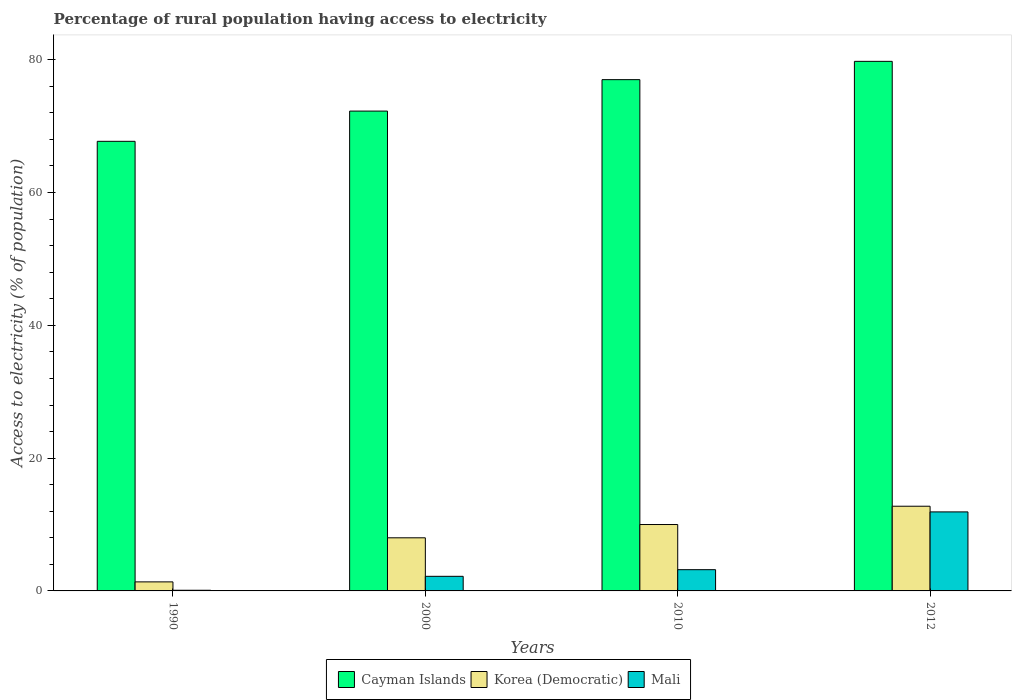How many groups of bars are there?
Your answer should be very brief. 4. Are the number of bars per tick equal to the number of legend labels?
Your answer should be compact. Yes. Are the number of bars on each tick of the X-axis equal?
Your answer should be very brief. Yes. How many bars are there on the 2nd tick from the left?
Your answer should be compact. 3. How many bars are there on the 4th tick from the right?
Your answer should be very brief. 3. Across all years, what is the maximum percentage of rural population having access to electricity in Cayman Islands?
Make the answer very short. 79.75. Across all years, what is the minimum percentage of rural population having access to electricity in Korea (Democratic)?
Provide a short and direct response. 1.36. In which year was the percentage of rural population having access to electricity in Korea (Democratic) maximum?
Your response must be concise. 2012. In which year was the percentage of rural population having access to electricity in Korea (Democratic) minimum?
Your response must be concise. 1990. What is the total percentage of rural population having access to electricity in Korea (Democratic) in the graph?
Your response must be concise. 32.11. What is the difference between the percentage of rural population having access to electricity in Korea (Democratic) in 2000 and that in 2012?
Make the answer very short. -4.75. What is the difference between the percentage of rural population having access to electricity in Mali in 2000 and the percentage of rural population having access to electricity in Cayman Islands in 2012?
Your response must be concise. -77.55. What is the average percentage of rural population having access to electricity in Korea (Democratic) per year?
Offer a terse response. 8.03. In the year 2012, what is the difference between the percentage of rural population having access to electricity in Cayman Islands and percentage of rural population having access to electricity in Mali?
Ensure brevity in your answer.  67.85. What is the ratio of the percentage of rural population having access to electricity in Mali in 2000 to that in 2012?
Make the answer very short. 0.18. What is the difference between the highest and the second highest percentage of rural population having access to electricity in Cayman Islands?
Keep it short and to the point. 2.75. What is the difference between the highest and the lowest percentage of rural population having access to electricity in Cayman Islands?
Make the answer very short. 12.04. Is the sum of the percentage of rural population having access to electricity in Mali in 1990 and 2012 greater than the maximum percentage of rural population having access to electricity in Korea (Democratic) across all years?
Keep it short and to the point. No. What does the 1st bar from the left in 1990 represents?
Your answer should be compact. Cayman Islands. What does the 3rd bar from the right in 2010 represents?
Offer a very short reply. Cayman Islands. Is it the case that in every year, the sum of the percentage of rural population having access to electricity in Korea (Democratic) and percentage of rural population having access to electricity in Cayman Islands is greater than the percentage of rural population having access to electricity in Mali?
Provide a succinct answer. Yes. Are all the bars in the graph horizontal?
Your response must be concise. No. How many years are there in the graph?
Your answer should be compact. 4. Does the graph contain any zero values?
Provide a short and direct response. No. How many legend labels are there?
Make the answer very short. 3. How are the legend labels stacked?
Ensure brevity in your answer.  Horizontal. What is the title of the graph?
Your answer should be very brief. Percentage of rural population having access to electricity. What is the label or title of the Y-axis?
Offer a terse response. Access to electricity (% of population). What is the Access to electricity (% of population) in Cayman Islands in 1990?
Your answer should be very brief. 67.71. What is the Access to electricity (% of population) in Korea (Democratic) in 1990?
Offer a very short reply. 1.36. What is the Access to electricity (% of population) in Mali in 1990?
Make the answer very short. 0.1. What is the Access to electricity (% of population) of Cayman Islands in 2000?
Your answer should be compact. 72.27. What is the Access to electricity (% of population) in Korea (Democratic) in 2000?
Offer a terse response. 8. What is the Access to electricity (% of population) in Korea (Democratic) in 2010?
Provide a short and direct response. 10. What is the Access to electricity (% of population) of Mali in 2010?
Give a very brief answer. 3.2. What is the Access to electricity (% of population) of Cayman Islands in 2012?
Give a very brief answer. 79.75. What is the Access to electricity (% of population) of Korea (Democratic) in 2012?
Provide a short and direct response. 12.75. What is the Access to electricity (% of population) of Mali in 2012?
Give a very brief answer. 11.9. Across all years, what is the maximum Access to electricity (% of population) in Cayman Islands?
Your answer should be very brief. 79.75. Across all years, what is the maximum Access to electricity (% of population) of Korea (Democratic)?
Your answer should be compact. 12.75. Across all years, what is the maximum Access to electricity (% of population) of Mali?
Keep it short and to the point. 11.9. Across all years, what is the minimum Access to electricity (% of population) of Cayman Islands?
Make the answer very short. 67.71. Across all years, what is the minimum Access to electricity (% of population) in Korea (Democratic)?
Offer a very short reply. 1.36. What is the total Access to electricity (% of population) in Cayman Islands in the graph?
Provide a short and direct response. 296.73. What is the total Access to electricity (% of population) in Korea (Democratic) in the graph?
Your response must be concise. 32.11. What is the difference between the Access to electricity (% of population) in Cayman Islands in 1990 and that in 2000?
Make the answer very short. -4.55. What is the difference between the Access to electricity (% of population) in Korea (Democratic) in 1990 and that in 2000?
Offer a very short reply. -6.64. What is the difference between the Access to electricity (% of population) in Cayman Islands in 1990 and that in 2010?
Your answer should be very brief. -9.29. What is the difference between the Access to electricity (% of population) in Korea (Democratic) in 1990 and that in 2010?
Provide a succinct answer. -8.64. What is the difference between the Access to electricity (% of population) of Cayman Islands in 1990 and that in 2012?
Offer a very short reply. -12.04. What is the difference between the Access to electricity (% of population) in Korea (Democratic) in 1990 and that in 2012?
Your response must be concise. -11.39. What is the difference between the Access to electricity (% of population) in Mali in 1990 and that in 2012?
Your response must be concise. -11.8. What is the difference between the Access to electricity (% of population) of Cayman Islands in 2000 and that in 2010?
Offer a terse response. -4.74. What is the difference between the Access to electricity (% of population) of Korea (Democratic) in 2000 and that in 2010?
Offer a terse response. -2. What is the difference between the Access to electricity (% of population) of Mali in 2000 and that in 2010?
Give a very brief answer. -1. What is the difference between the Access to electricity (% of population) in Cayman Islands in 2000 and that in 2012?
Provide a short and direct response. -7.49. What is the difference between the Access to electricity (% of population) of Korea (Democratic) in 2000 and that in 2012?
Make the answer very short. -4.75. What is the difference between the Access to electricity (% of population) of Cayman Islands in 2010 and that in 2012?
Provide a short and direct response. -2.75. What is the difference between the Access to electricity (% of population) of Korea (Democratic) in 2010 and that in 2012?
Give a very brief answer. -2.75. What is the difference between the Access to electricity (% of population) of Cayman Islands in 1990 and the Access to electricity (% of population) of Korea (Democratic) in 2000?
Offer a very short reply. 59.71. What is the difference between the Access to electricity (% of population) in Cayman Islands in 1990 and the Access to electricity (% of population) in Mali in 2000?
Offer a very short reply. 65.51. What is the difference between the Access to electricity (% of population) in Korea (Democratic) in 1990 and the Access to electricity (% of population) in Mali in 2000?
Offer a terse response. -0.84. What is the difference between the Access to electricity (% of population) of Cayman Islands in 1990 and the Access to electricity (% of population) of Korea (Democratic) in 2010?
Provide a short and direct response. 57.71. What is the difference between the Access to electricity (% of population) in Cayman Islands in 1990 and the Access to electricity (% of population) in Mali in 2010?
Give a very brief answer. 64.51. What is the difference between the Access to electricity (% of population) in Korea (Democratic) in 1990 and the Access to electricity (% of population) in Mali in 2010?
Your answer should be very brief. -1.84. What is the difference between the Access to electricity (% of population) of Cayman Islands in 1990 and the Access to electricity (% of population) of Korea (Democratic) in 2012?
Offer a very short reply. 54.96. What is the difference between the Access to electricity (% of population) in Cayman Islands in 1990 and the Access to electricity (% of population) in Mali in 2012?
Your response must be concise. 55.81. What is the difference between the Access to electricity (% of population) of Korea (Democratic) in 1990 and the Access to electricity (% of population) of Mali in 2012?
Provide a succinct answer. -10.54. What is the difference between the Access to electricity (% of population) of Cayman Islands in 2000 and the Access to electricity (% of population) of Korea (Democratic) in 2010?
Ensure brevity in your answer.  62.27. What is the difference between the Access to electricity (% of population) in Cayman Islands in 2000 and the Access to electricity (% of population) in Mali in 2010?
Provide a succinct answer. 69.06. What is the difference between the Access to electricity (% of population) of Korea (Democratic) in 2000 and the Access to electricity (% of population) of Mali in 2010?
Your answer should be compact. 4.8. What is the difference between the Access to electricity (% of population) of Cayman Islands in 2000 and the Access to electricity (% of population) of Korea (Democratic) in 2012?
Offer a very short reply. 59.51. What is the difference between the Access to electricity (% of population) of Cayman Islands in 2000 and the Access to electricity (% of population) of Mali in 2012?
Your answer should be very brief. 60.37. What is the difference between the Access to electricity (% of population) of Korea (Democratic) in 2000 and the Access to electricity (% of population) of Mali in 2012?
Keep it short and to the point. -3.9. What is the difference between the Access to electricity (% of population) of Cayman Islands in 2010 and the Access to electricity (% of population) of Korea (Democratic) in 2012?
Make the answer very short. 64.25. What is the difference between the Access to electricity (% of population) of Cayman Islands in 2010 and the Access to electricity (% of population) of Mali in 2012?
Ensure brevity in your answer.  65.1. What is the difference between the Access to electricity (% of population) of Korea (Democratic) in 2010 and the Access to electricity (% of population) of Mali in 2012?
Your answer should be very brief. -1.9. What is the average Access to electricity (% of population) of Cayman Islands per year?
Give a very brief answer. 74.18. What is the average Access to electricity (% of population) in Korea (Democratic) per year?
Offer a very short reply. 8.03. What is the average Access to electricity (% of population) of Mali per year?
Offer a very short reply. 4.35. In the year 1990, what is the difference between the Access to electricity (% of population) of Cayman Islands and Access to electricity (% of population) of Korea (Democratic)?
Keep it short and to the point. 66.35. In the year 1990, what is the difference between the Access to electricity (% of population) of Cayman Islands and Access to electricity (% of population) of Mali?
Offer a terse response. 67.61. In the year 1990, what is the difference between the Access to electricity (% of population) of Korea (Democratic) and Access to electricity (% of population) of Mali?
Give a very brief answer. 1.26. In the year 2000, what is the difference between the Access to electricity (% of population) of Cayman Islands and Access to electricity (% of population) of Korea (Democratic)?
Your response must be concise. 64.27. In the year 2000, what is the difference between the Access to electricity (% of population) in Cayman Islands and Access to electricity (% of population) in Mali?
Offer a terse response. 70.06. In the year 2000, what is the difference between the Access to electricity (% of population) in Korea (Democratic) and Access to electricity (% of population) in Mali?
Provide a succinct answer. 5.8. In the year 2010, what is the difference between the Access to electricity (% of population) in Cayman Islands and Access to electricity (% of population) in Korea (Democratic)?
Your response must be concise. 67. In the year 2010, what is the difference between the Access to electricity (% of population) of Cayman Islands and Access to electricity (% of population) of Mali?
Your answer should be very brief. 73.8. In the year 2010, what is the difference between the Access to electricity (% of population) of Korea (Democratic) and Access to electricity (% of population) of Mali?
Provide a succinct answer. 6.8. In the year 2012, what is the difference between the Access to electricity (% of population) of Cayman Islands and Access to electricity (% of population) of Mali?
Offer a terse response. 67.85. In the year 2012, what is the difference between the Access to electricity (% of population) of Korea (Democratic) and Access to electricity (% of population) of Mali?
Ensure brevity in your answer.  0.85. What is the ratio of the Access to electricity (% of population) of Cayman Islands in 1990 to that in 2000?
Ensure brevity in your answer.  0.94. What is the ratio of the Access to electricity (% of population) in Korea (Democratic) in 1990 to that in 2000?
Provide a succinct answer. 0.17. What is the ratio of the Access to electricity (% of population) in Mali in 1990 to that in 2000?
Your answer should be compact. 0.05. What is the ratio of the Access to electricity (% of population) of Cayman Islands in 1990 to that in 2010?
Make the answer very short. 0.88. What is the ratio of the Access to electricity (% of population) in Korea (Democratic) in 1990 to that in 2010?
Provide a succinct answer. 0.14. What is the ratio of the Access to electricity (% of population) of Mali in 1990 to that in 2010?
Provide a short and direct response. 0.03. What is the ratio of the Access to electricity (% of population) in Cayman Islands in 1990 to that in 2012?
Ensure brevity in your answer.  0.85. What is the ratio of the Access to electricity (% of population) of Korea (Democratic) in 1990 to that in 2012?
Your answer should be very brief. 0.11. What is the ratio of the Access to electricity (% of population) of Mali in 1990 to that in 2012?
Your answer should be compact. 0.01. What is the ratio of the Access to electricity (% of population) of Cayman Islands in 2000 to that in 2010?
Your response must be concise. 0.94. What is the ratio of the Access to electricity (% of population) of Mali in 2000 to that in 2010?
Provide a short and direct response. 0.69. What is the ratio of the Access to electricity (% of population) in Cayman Islands in 2000 to that in 2012?
Keep it short and to the point. 0.91. What is the ratio of the Access to electricity (% of population) in Korea (Democratic) in 2000 to that in 2012?
Your response must be concise. 0.63. What is the ratio of the Access to electricity (% of population) of Mali in 2000 to that in 2012?
Keep it short and to the point. 0.18. What is the ratio of the Access to electricity (% of population) in Cayman Islands in 2010 to that in 2012?
Your response must be concise. 0.97. What is the ratio of the Access to electricity (% of population) in Korea (Democratic) in 2010 to that in 2012?
Give a very brief answer. 0.78. What is the ratio of the Access to electricity (% of population) in Mali in 2010 to that in 2012?
Give a very brief answer. 0.27. What is the difference between the highest and the second highest Access to electricity (% of population) of Cayman Islands?
Provide a succinct answer. 2.75. What is the difference between the highest and the second highest Access to electricity (% of population) in Korea (Democratic)?
Make the answer very short. 2.75. What is the difference between the highest and the second highest Access to electricity (% of population) of Mali?
Give a very brief answer. 8.7. What is the difference between the highest and the lowest Access to electricity (% of population) of Cayman Islands?
Your answer should be compact. 12.04. What is the difference between the highest and the lowest Access to electricity (% of population) of Korea (Democratic)?
Your answer should be very brief. 11.39. What is the difference between the highest and the lowest Access to electricity (% of population) in Mali?
Make the answer very short. 11.8. 